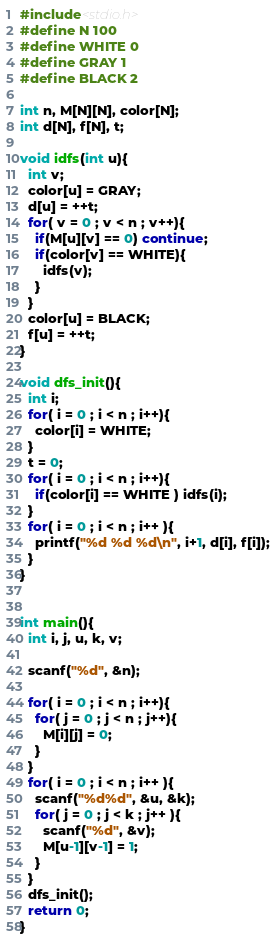<code> <loc_0><loc_0><loc_500><loc_500><_C_>#include<stdio.h>
#define N 100
#define WHITE 0
#define GRAY 1
#define BLACK 2

int n, M[N][N], color[N];
int d[N], f[N], t;

void idfs(int u){
  int v;
  color[u] = GRAY;
  d[u] = ++t;
  for( v = 0 ; v < n ; v++){
    if(M[u][v] == 0) continue;
    if(color[v] == WHITE){
      idfs(v);
    }
  }
  color[u] = BLACK;
  f[u] = ++t;
}

void dfs_init(){
  int i;
  for( i = 0 ; i < n ; i++){
    color[i] = WHITE;
  }
  t = 0;
  for( i = 0 ; i < n ; i++){
    if(color[i] == WHITE ) idfs(i);
  }
  for( i = 0 ; i < n ; i++ ){
    printf("%d %d %d\n", i+1, d[i], f[i]);
  }
}


int main(){
  int i, j, u, k, v;

  scanf("%d", &n);

  for( i = 0 ; i < n ; i++){
    for( j = 0 ; j < n ; j++){
      M[i][j] = 0;
    }
  }
  for( i = 0 ; i < n ; i++ ){
    scanf("%d%d", &u, &k);
    for( j = 0 ; j < k ; j++ ){
      scanf("%d", &v);
      M[u-1][v-1] = 1;
    }
  }
  dfs_init();
  return 0;
}

</code> 